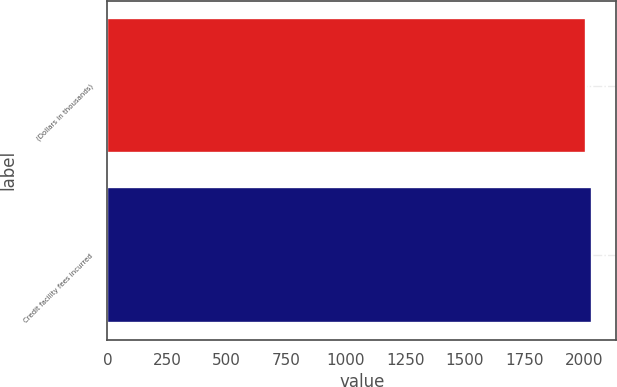Convert chart to OTSL. <chart><loc_0><loc_0><loc_500><loc_500><bar_chart><fcel>(Dollars in thousands)<fcel>Credit facility fees incurred<nl><fcel>2010<fcel>2034<nl></chart> 